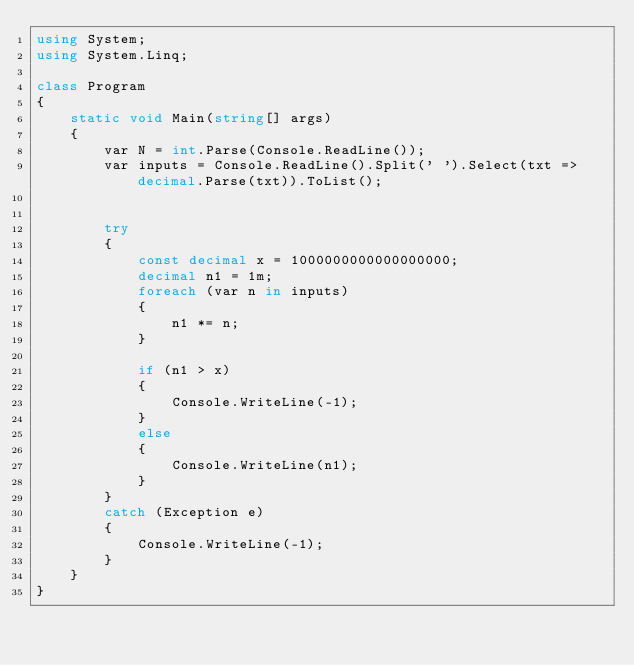Convert code to text. <code><loc_0><loc_0><loc_500><loc_500><_C#_>using System;
using System.Linq;

class Program
{
    static void Main(string[] args)
    {
        var N = int.Parse(Console.ReadLine());
        var inputs = Console.ReadLine().Split(' ').Select(txt => decimal.Parse(txt)).ToList();


        try
        {
            const decimal x = 1000000000000000000;
            decimal n1 = 1m;
            foreach (var n in inputs)
            {
                n1 *= n;
            }

            if (n1 > x)
            {
                Console.WriteLine(-1);
            }
            else
            {
                Console.WriteLine(n1);
            }
        }
        catch (Exception e)
        {
            Console.WriteLine(-1);
        }
    }
}</code> 